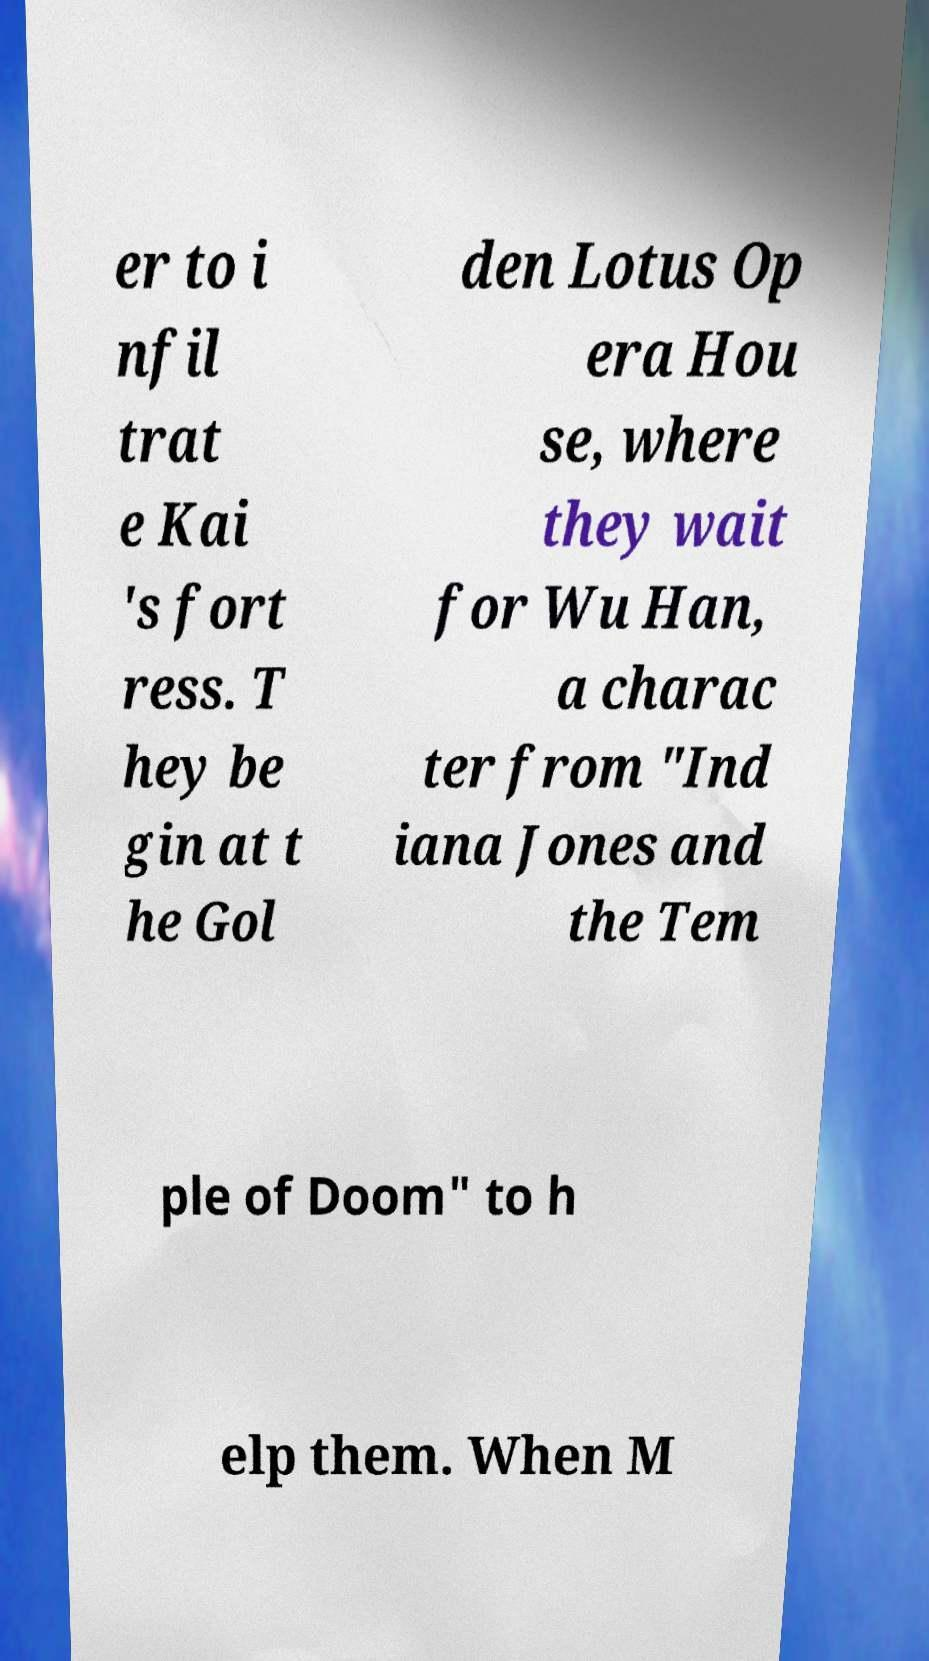Could you assist in decoding the text presented in this image and type it out clearly? er to i nfil trat e Kai 's fort ress. T hey be gin at t he Gol den Lotus Op era Hou se, where they wait for Wu Han, a charac ter from "Ind iana Jones and the Tem ple of Doom" to h elp them. When M 